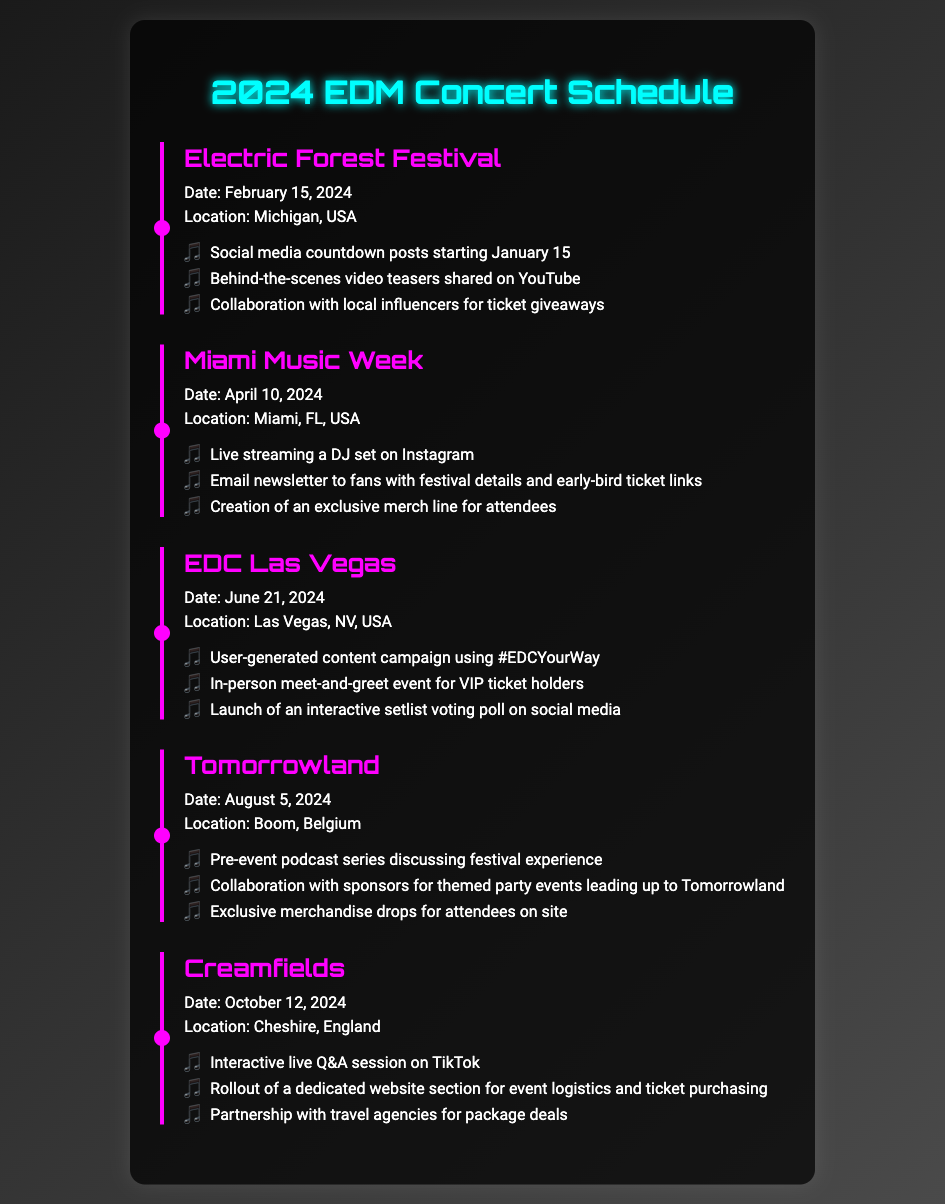What is the date of the Electric Forest Festival? The Electric Forest Festival is scheduled for February 15, 2024.
Answer: February 15, 2024 Where is the Miami Music Week taking place? Miami Music Week will occur in Miami, FL, USA.
Answer: Miami, FL, USA What is one promotional activity planned for EDC Las Vegas? One promotional activity for EDC Las Vegas includes a user-generated content campaign using #EDCYourWay.
Answer: User-generated content campaign using #EDCYourWay How many events are listed in the concert schedule? There are five events outlined in the document: Electric Forest Festival, Miami Music Week, EDC Las Vegas, Tomorrowland, and Creamfields.
Answer: Five Which festival is scheduled for August 5, 2024? Tomorrowland is set to take place on August 5, 2024, in Boom, Belgium.
Answer: Tomorrowland What special activity is planned for VIP ticket holders at EDC Las Vegas? A meet-and-greet event is planned for VIP ticket holders at EDC Las Vegas.
Answer: Meet-and-greet event How will the promotional activities for Creamfields be executed? Creamfields will include an interactive live Q&A session on TikTok as one of its promotional activities.
Answer: Interactive live Q&A session on TikTok What type of merchandise will be created for the Miami Music Week? An exclusive merch line for attendees will be created for the Miami Music Week.
Answer: Exclusive merch line for attendees 